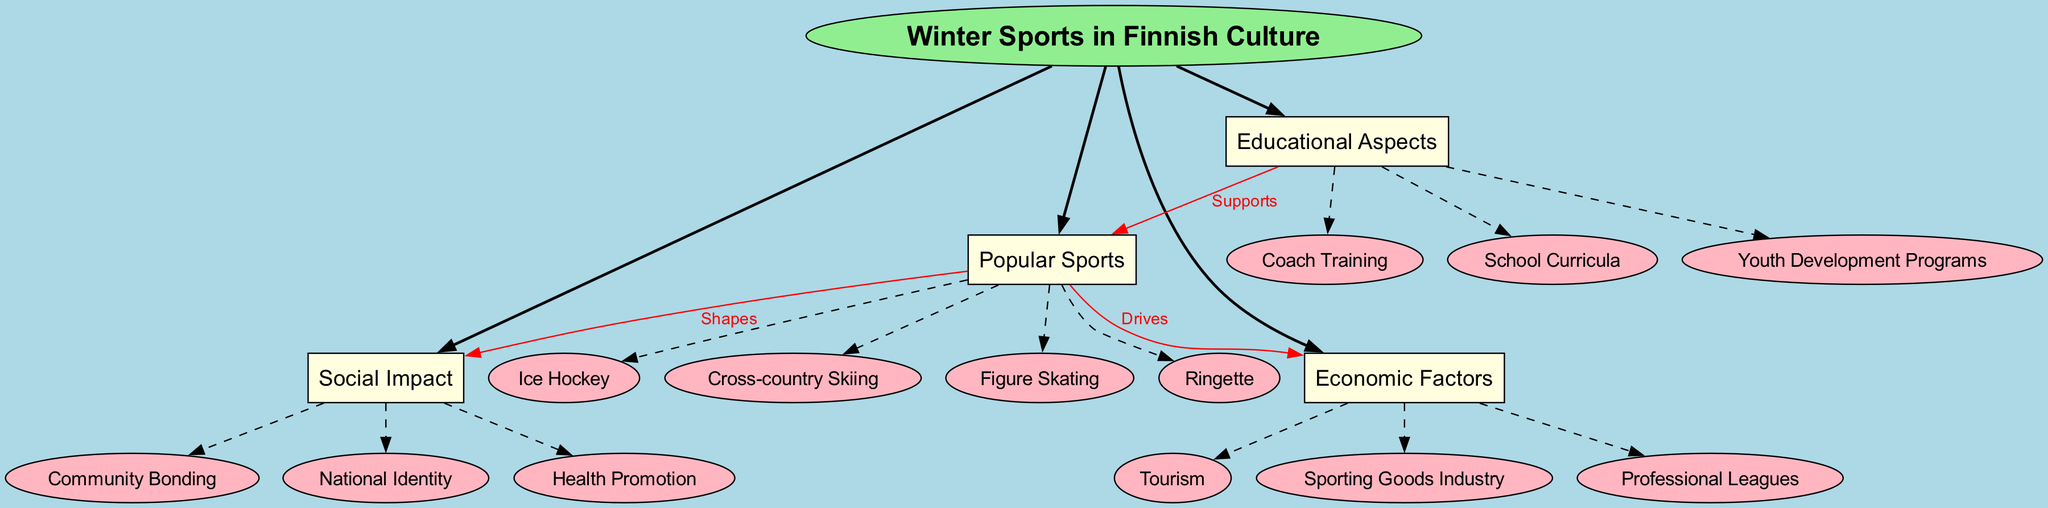What is the central concept of the diagram? The diagram starts with a central concept node labeled "Winter Sports in Finnish Culture". This is the main idea that the other nodes expand upon.
Answer: Winter Sports in Finnish Culture How many main branches are there? There are four main branches stemming from the central concept, which are "Popular Sports", "Social Impact", "Economic Factors", and "Educational Aspects". Counting these distinct branches gives a total of four.
Answer: 4 Which sport is listed under the "Popular Sports" branch? The "Popular Sports" branch includes several sub-branches, one of which explicitly mentions "Ringette". This sport is part of the prominent categories that fall under winter sports in the context of Finnish culture.
Answer: Ringette What does the arrow labeled "Shapes" connect? The arrow labeled "Shapes" connects the "Popular Sports" branch to the "Social Impact" branch, indicating that popular sports influence or define aspects of social dynamics in Finnish society.
Answer: Popular Sports to Social Impact Name one aspect included in the "Economic Factors" branch. The "Economic Factors" branch has several sub-branches, such as "Tourism", "Sporting Goods Industry", and "Professional Leagues". For example, "Tourism" highlights one significant economic aspect connected to winter sports in Finland.
Answer: Tourism Which branch includes "Coach Training"? "Coach Training" is a sub-branch found in the "Educational Aspects" category. This indicates a focus on the systematic preparation and education of coaches, which is crucial for developing athletes and winter sports in Finland.
Answer: Educational Aspects What relationship is indicated between "Popular Sports" and "Economic Factors"? The connection from "Popular Sports" to "Economic Factors" is labeled "Drives". This suggests that the popularity of winter sports in Finland actively contributes to economic activities, such as growth in related industries.
Answer: Drives How do educational aspects relate to popular sports? Educational aspects connect to popular sports through the edge labeled "Supports". This implies that various educational initiatives, such as training programs, are designed to nurture and enhance participation in popular sports.
Answer: Supports What does "Health Promotion" signify in the context of the diagram? "Health Promotion" is a sub-branch under "Social Impact", indicating that engaging in winter sports contributes positively to community health and wellness in Finnish society.
Answer: Health Promotion 